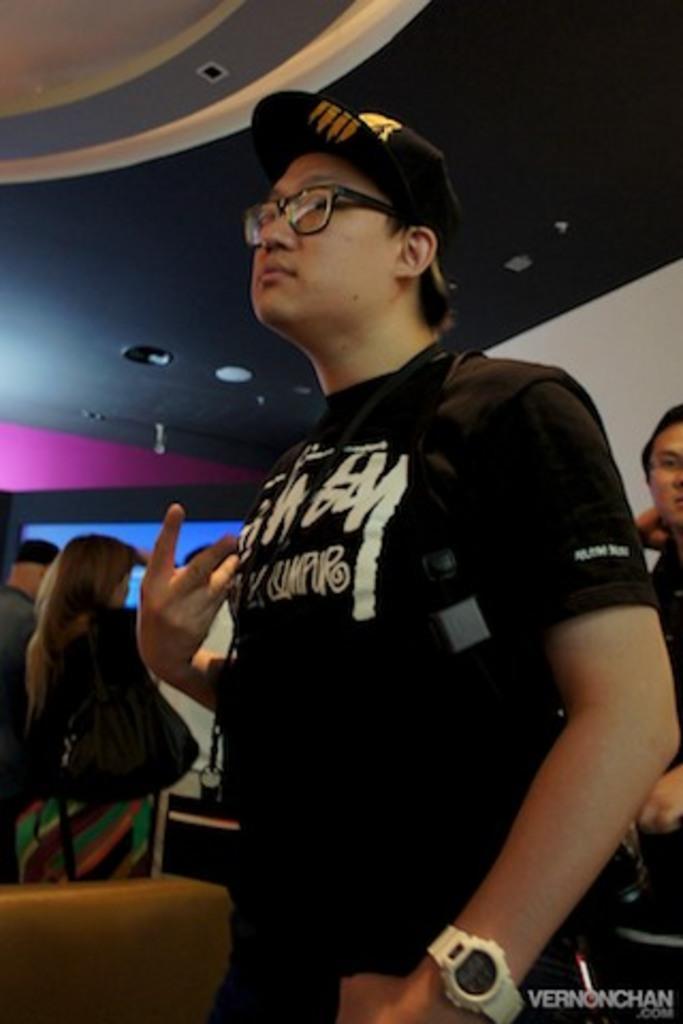In one or two sentences, can you explain what this image depicts? In this image, I can see a group of people standing. At the top of the image, there is a ceiling. At the bottom right side of the image, I can see a watermark. 